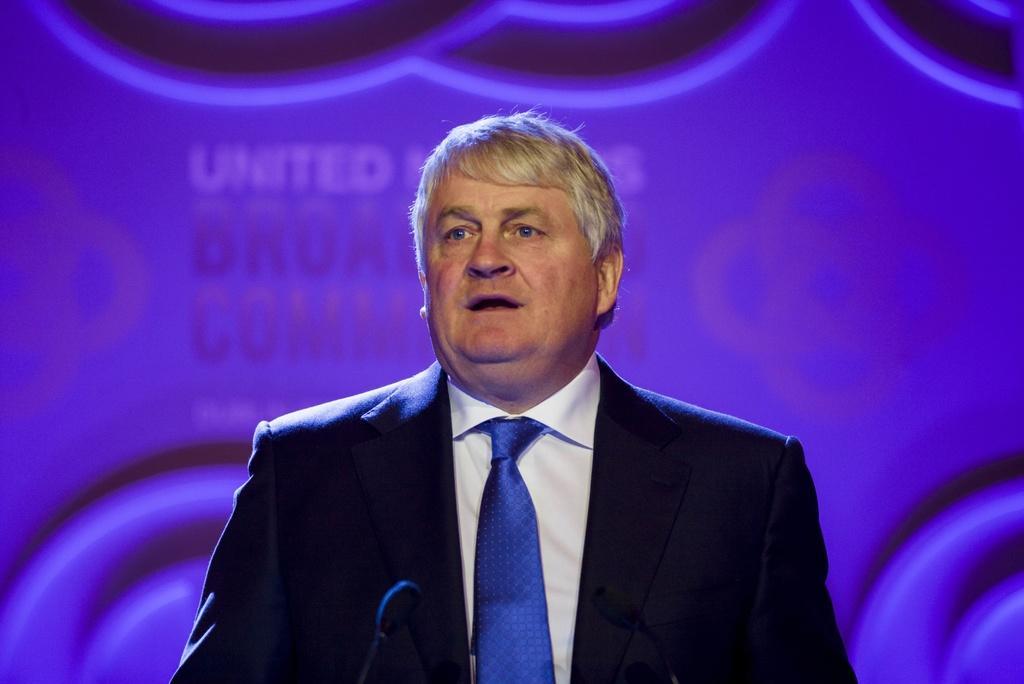In one or two sentences, can you explain what this image depicts? In the foreground of the picture there is a man wearing black suit and blue tie, talking. In front of him there is a mic. In the background there is a violet color hoarding. 